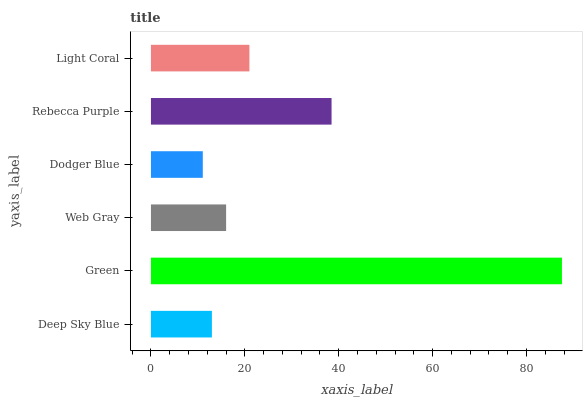Is Dodger Blue the minimum?
Answer yes or no. Yes. Is Green the maximum?
Answer yes or no. Yes. Is Web Gray the minimum?
Answer yes or no. No. Is Web Gray the maximum?
Answer yes or no. No. Is Green greater than Web Gray?
Answer yes or no. Yes. Is Web Gray less than Green?
Answer yes or no. Yes. Is Web Gray greater than Green?
Answer yes or no. No. Is Green less than Web Gray?
Answer yes or no. No. Is Light Coral the high median?
Answer yes or no. Yes. Is Web Gray the low median?
Answer yes or no. Yes. Is Deep Sky Blue the high median?
Answer yes or no. No. Is Dodger Blue the low median?
Answer yes or no. No. 